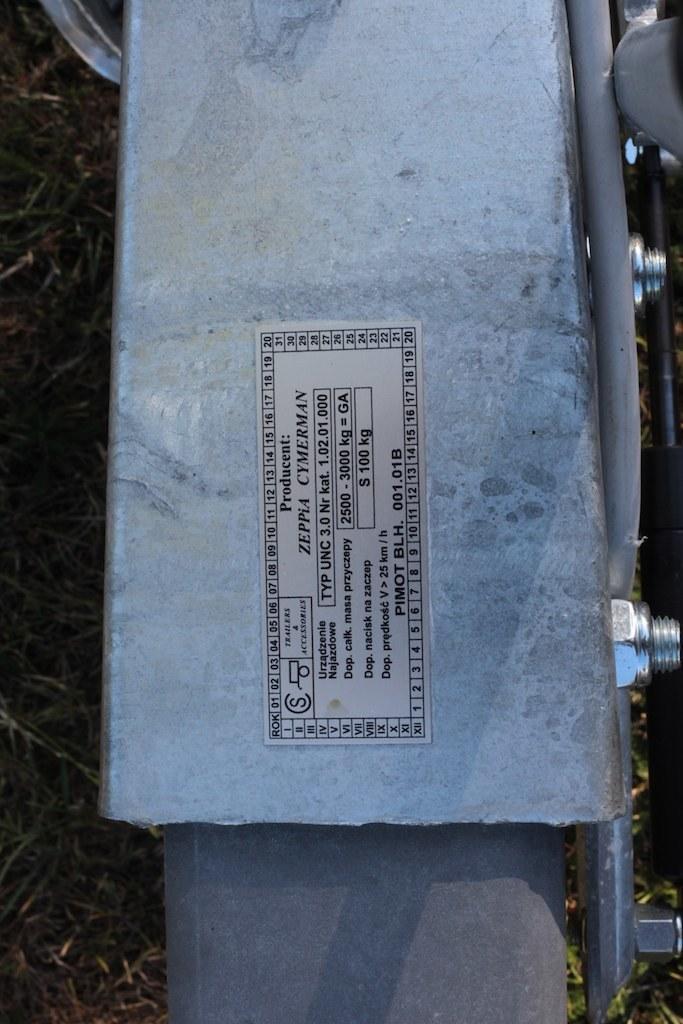In one or two sentences, can you explain what this image depicts? In this picture we can see a sticker on a platform, screws, rod and in the background we can see the grass. 